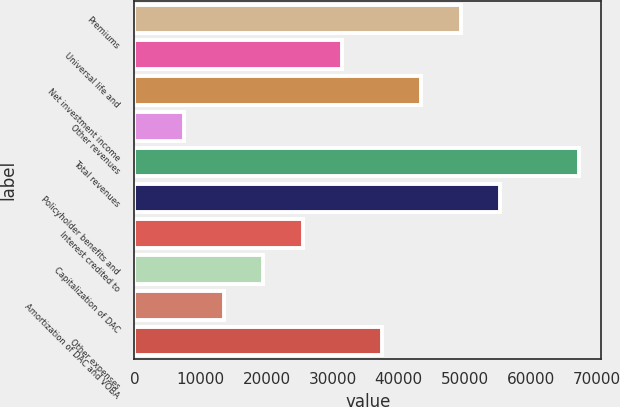Convert chart to OTSL. <chart><loc_0><loc_0><loc_500><loc_500><bar_chart><fcel>Premiums<fcel>Universal life and<fcel>Net investment income<fcel>Other revenues<fcel>Total revenues<fcel>Policyholder benefits and<fcel>Interest credited to<fcel>Capitalization of DAC<fcel>Amortization of DAC and VOBA<fcel>Other expenses<nl><fcel>49392.4<fcel>31466.5<fcel>43417.1<fcel>7565.3<fcel>67318.3<fcel>55367.7<fcel>25491.2<fcel>19515.9<fcel>13540.6<fcel>37441.8<nl></chart> 